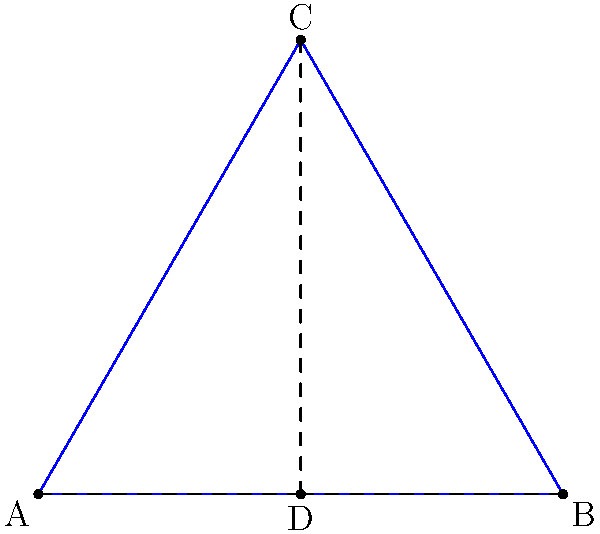In a military formation, soldiers are positioned at points A, B, and C, forming an equilateral triangle. The formation commander stands at point D, which is the centroid of the triangle. How many rotational symmetries does this formation possess, excluding the identity transformation? To determine the number of rotational symmetries, we need to follow these steps:

1. Recognize that the formation is based on an equilateral triangle ABC.

2. Recall that an equilateral triangle has 3-fold rotational symmetry, meaning it can be rotated by 120° and 240° (as well as 360°, which is the identity transformation) and still look the same.

3. Consider the position of the commander at point D:
   - D is at the centroid of the triangle, which is the intersection of the three medians.
   - The centroid divides each median in a 2:1 ratio, closer to the midpoint of a side.

4. Observe that rotating the entire formation (including the commander) by 120° or 240° around the center will produce an identical configuration.

5. Count the number of non-identity rotations that preserve the formation:
   - 120° rotation (clockwise or counterclockwise)
   - 240° rotation (clockwise or counterclockwise)

6. Therefore, there are 2 rotational symmetries, not counting the identity transformation (360° rotation).
Answer: 2 